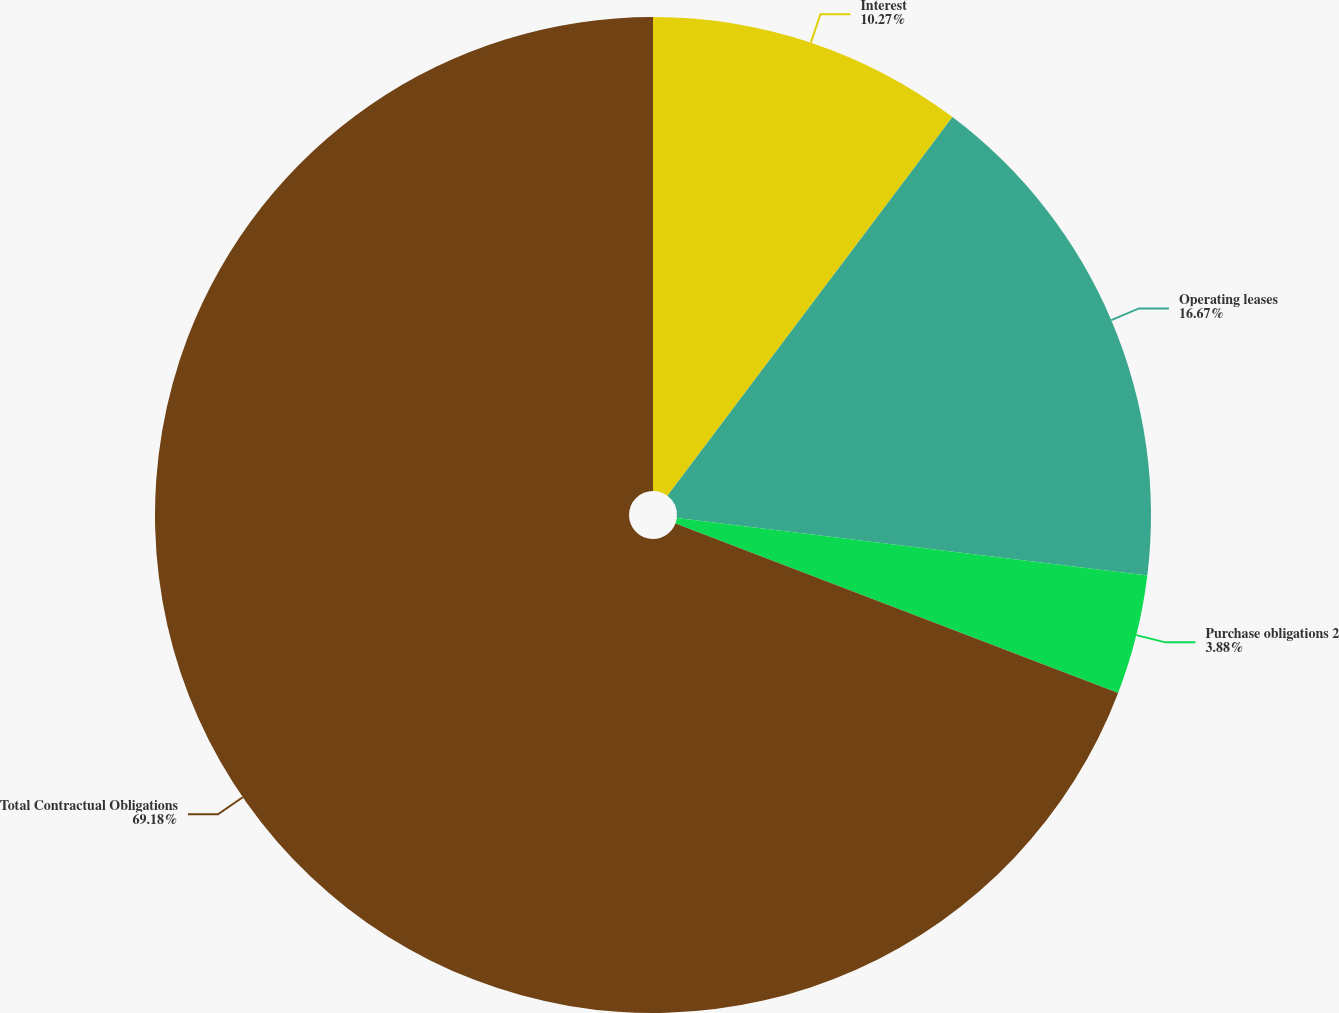<chart> <loc_0><loc_0><loc_500><loc_500><pie_chart><fcel>Interest<fcel>Operating leases<fcel>Purchase obligations 2<fcel>Total Contractual Obligations<nl><fcel>10.27%<fcel>16.67%<fcel>3.88%<fcel>69.19%<nl></chart> 